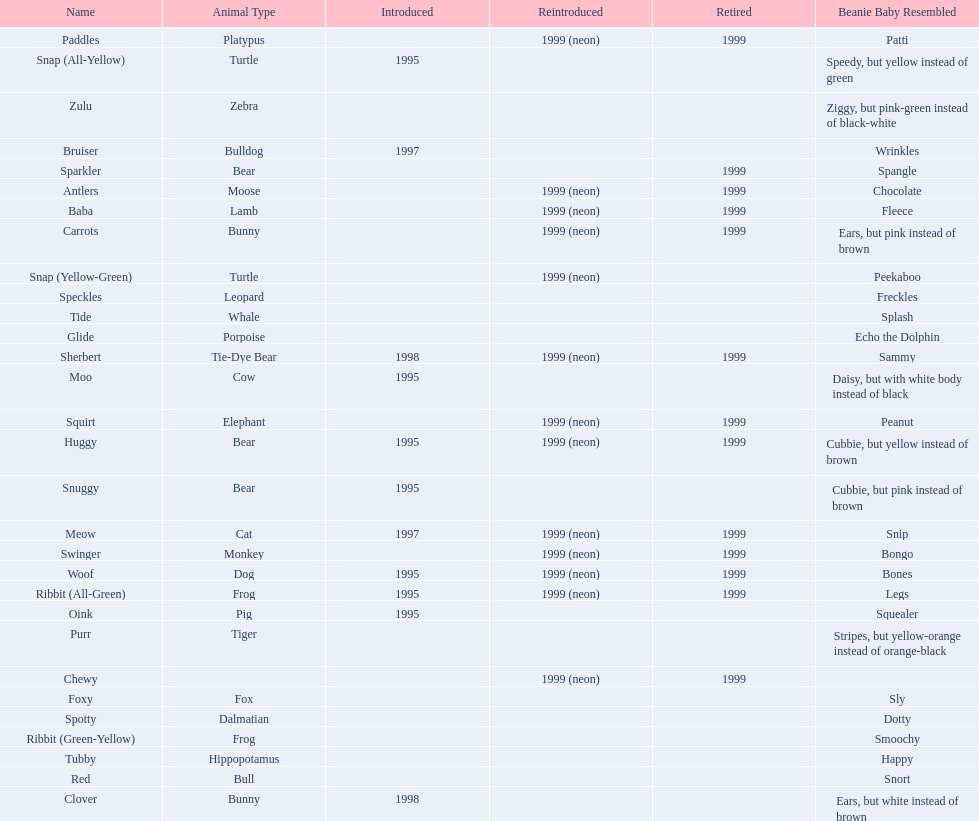In what year were the first pillow pals introduced? 1995. 